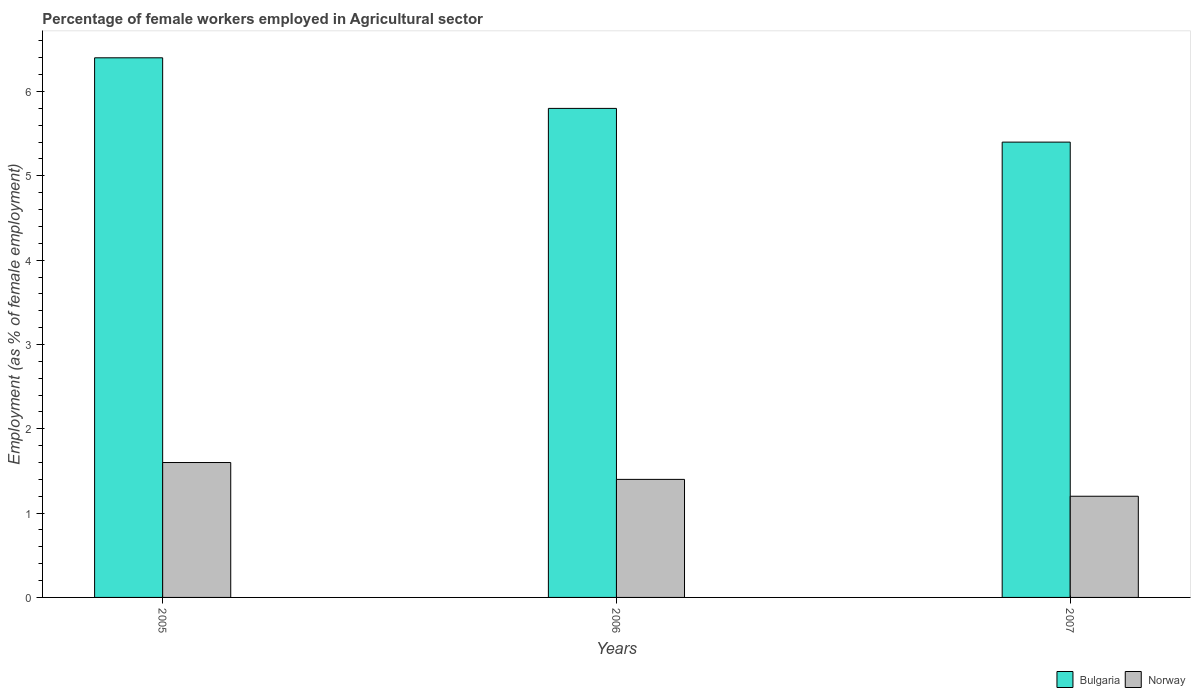How many different coloured bars are there?
Give a very brief answer. 2. How many groups of bars are there?
Your response must be concise. 3. Are the number of bars on each tick of the X-axis equal?
Provide a succinct answer. Yes. How many bars are there on the 1st tick from the left?
Your answer should be compact. 2. How many bars are there on the 2nd tick from the right?
Your response must be concise. 2. What is the label of the 3rd group of bars from the left?
Your answer should be compact. 2007. In how many cases, is the number of bars for a given year not equal to the number of legend labels?
Provide a short and direct response. 0. What is the percentage of females employed in Agricultural sector in Bulgaria in 2007?
Your answer should be compact. 5.4. Across all years, what is the maximum percentage of females employed in Agricultural sector in Bulgaria?
Your answer should be very brief. 6.4. Across all years, what is the minimum percentage of females employed in Agricultural sector in Norway?
Give a very brief answer. 1.2. What is the total percentage of females employed in Agricultural sector in Bulgaria in the graph?
Provide a succinct answer. 17.6. What is the difference between the percentage of females employed in Agricultural sector in Bulgaria in 2005 and that in 2006?
Your answer should be very brief. 0.6. What is the difference between the percentage of females employed in Agricultural sector in Norway in 2005 and the percentage of females employed in Agricultural sector in Bulgaria in 2006?
Offer a very short reply. -4.2. What is the average percentage of females employed in Agricultural sector in Norway per year?
Your answer should be compact. 1.4. In the year 2006, what is the difference between the percentage of females employed in Agricultural sector in Norway and percentage of females employed in Agricultural sector in Bulgaria?
Keep it short and to the point. -4.4. In how many years, is the percentage of females employed in Agricultural sector in Norway greater than 1.2 %?
Give a very brief answer. 3. What is the ratio of the percentage of females employed in Agricultural sector in Bulgaria in 2005 to that in 2006?
Offer a very short reply. 1.1. Is the percentage of females employed in Agricultural sector in Bulgaria in 2006 less than that in 2007?
Offer a very short reply. No. What is the difference between the highest and the second highest percentage of females employed in Agricultural sector in Bulgaria?
Your answer should be very brief. 0.6. What is the difference between the highest and the lowest percentage of females employed in Agricultural sector in Norway?
Your response must be concise. 0.4. In how many years, is the percentage of females employed in Agricultural sector in Bulgaria greater than the average percentage of females employed in Agricultural sector in Bulgaria taken over all years?
Provide a short and direct response. 1. Is the sum of the percentage of females employed in Agricultural sector in Norway in 2005 and 2007 greater than the maximum percentage of females employed in Agricultural sector in Bulgaria across all years?
Provide a short and direct response. No. How many bars are there?
Provide a short and direct response. 6. Are all the bars in the graph horizontal?
Ensure brevity in your answer.  No. What is the difference between two consecutive major ticks on the Y-axis?
Your response must be concise. 1. Where does the legend appear in the graph?
Make the answer very short. Bottom right. How many legend labels are there?
Offer a very short reply. 2. What is the title of the graph?
Offer a very short reply. Percentage of female workers employed in Agricultural sector. What is the label or title of the X-axis?
Offer a very short reply. Years. What is the label or title of the Y-axis?
Your answer should be very brief. Employment (as % of female employment). What is the Employment (as % of female employment) of Bulgaria in 2005?
Your answer should be compact. 6.4. What is the Employment (as % of female employment) in Norway in 2005?
Provide a short and direct response. 1.6. What is the Employment (as % of female employment) of Bulgaria in 2006?
Offer a terse response. 5.8. What is the Employment (as % of female employment) in Norway in 2006?
Your answer should be compact. 1.4. What is the Employment (as % of female employment) of Bulgaria in 2007?
Your response must be concise. 5.4. What is the Employment (as % of female employment) in Norway in 2007?
Keep it short and to the point. 1.2. Across all years, what is the maximum Employment (as % of female employment) in Bulgaria?
Keep it short and to the point. 6.4. Across all years, what is the maximum Employment (as % of female employment) in Norway?
Provide a short and direct response. 1.6. Across all years, what is the minimum Employment (as % of female employment) of Bulgaria?
Keep it short and to the point. 5.4. Across all years, what is the minimum Employment (as % of female employment) of Norway?
Your answer should be very brief. 1.2. What is the total Employment (as % of female employment) in Bulgaria in the graph?
Your answer should be compact. 17.6. What is the total Employment (as % of female employment) of Norway in the graph?
Ensure brevity in your answer.  4.2. What is the difference between the Employment (as % of female employment) in Bulgaria in 2005 and that in 2007?
Offer a very short reply. 1. What is the difference between the Employment (as % of female employment) of Norway in 2005 and that in 2007?
Offer a very short reply. 0.4. What is the difference between the Employment (as % of female employment) of Norway in 2006 and that in 2007?
Your answer should be compact. 0.2. What is the difference between the Employment (as % of female employment) in Bulgaria in 2005 and the Employment (as % of female employment) in Norway in 2006?
Give a very brief answer. 5. What is the difference between the Employment (as % of female employment) of Bulgaria in 2005 and the Employment (as % of female employment) of Norway in 2007?
Your answer should be compact. 5.2. What is the difference between the Employment (as % of female employment) in Bulgaria in 2006 and the Employment (as % of female employment) in Norway in 2007?
Your response must be concise. 4.6. What is the average Employment (as % of female employment) of Bulgaria per year?
Give a very brief answer. 5.87. In the year 2005, what is the difference between the Employment (as % of female employment) of Bulgaria and Employment (as % of female employment) of Norway?
Offer a very short reply. 4.8. In the year 2006, what is the difference between the Employment (as % of female employment) in Bulgaria and Employment (as % of female employment) in Norway?
Your response must be concise. 4.4. In the year 2007, what is the difference between the Employment (as % of female employment) of Bulgaria and Employment (as % of female employment) of Norway?
Provide a succinct answer. 4.2. What is the ratio of the Employment (as % of female employment) in Bulgaria in 2005 to that in 2006?
Keep it short and to the point. 1.1. What is the ratio of the Employment (as % of female employment) in Norway in 2005 to that in 2006?
Make the answer very short. 1.14. What is the ratio of the Employment (as % of female employment) of Bulgaria in 2005 to that in 2007?
Provide a short and direct response. 1.19. What is the ratio of the Employment (as % of female employment) of Norway in 2005 to that in 2007?
Your answer should be very brief. 1.33. What is the ratio of the Employment (as % of female employment) of Bulgaria in 2006 to that in 2007?
Make the answer very short. 1.07. What is the ratio of the Employment (as % of female employment) of Norway in 2006 to that in 2007?
Provide a short and direct response. 1.17. What is the difference between the highest and the lowest Employment (as % of female employment) of Bulgaria?
Offer a terse response. 1. 